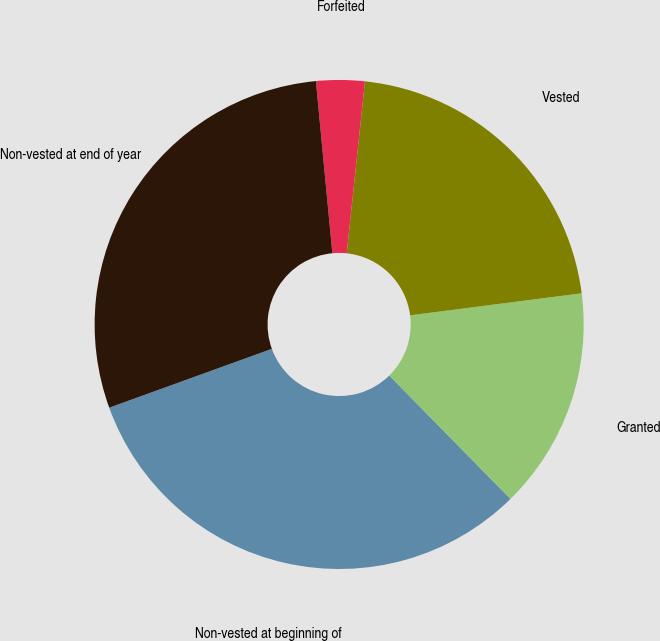Convert chart. <chart><loc_0><loc_0><loc_500><loc_500><pie_chart><fcel>Non-vested at beginning of<fcel>Granted<fcel>Vested<fcel>Forfeited<fcel>Non-vested at end of year<nl><fcel>31.83%<fcel>14.68%<fcel>21.28%<fcel>3.2%<fcel>29.01%<nl></chart> 